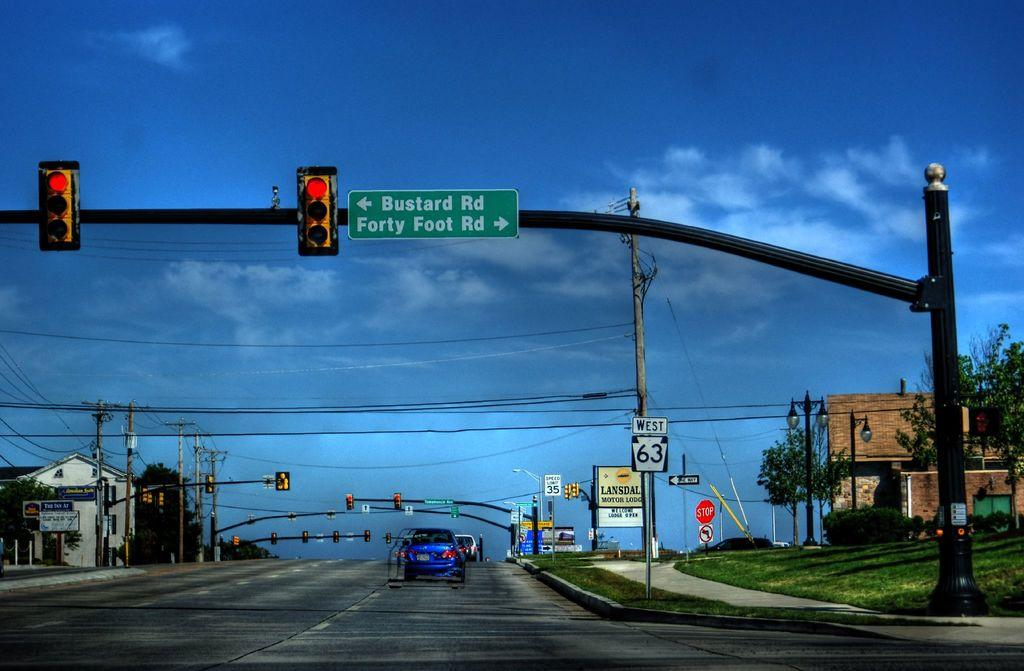<image>
Render a clear and concise summary of the photo. An intersection with a directional sign showing right to Forty Foot Rd and left to Bustard Rd. 